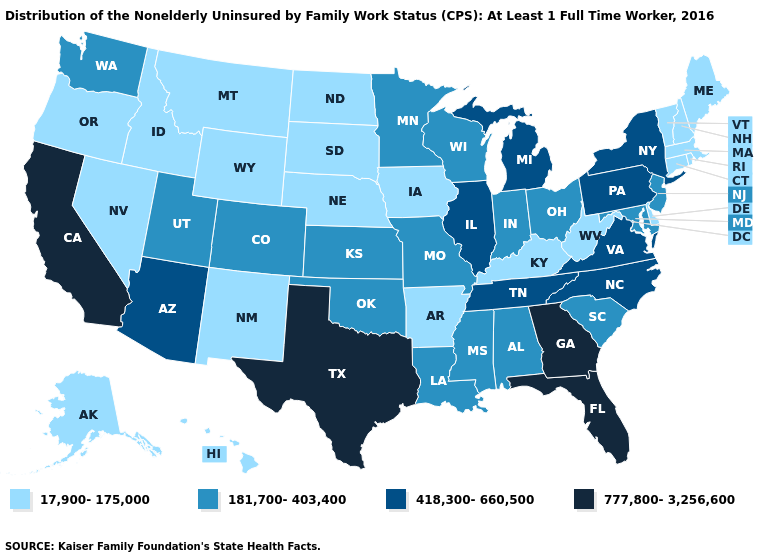Does Maryland have the highest value in the South?
Quick response, please. No. Which states have the lowest value in the West?
Give a very brief answer. Alaska, Hawaii, Idaho, Montana, Nevada, New Mexico, Oregon, Wyoming. Does Iowa have a lower value than Kentucky?
Give a very brief answer. No. What is the value of Rhode Island?
Give a very brief answer. 17,900-175,000. What is the value of Montana?
Keep it brief. 17,900-175,000. Name the states that have a value in the range 418,300-660,500?
Short answer required. Arizona, Illinois, Michigan, New York, North Carolina, Pennsylvania, Tennessee, Virginia. Among the states that border Vermont , which have the highest value?
Keep it brief. New York. Name the states that have a value in the range 777,800-3,256,600?
Short answer required. California, Florida, Georgia, Texas. Name the states that have a value in the range 418,300-660,500?
Give a very brief answer. Arizona, Illinois, Michigan, New York, North Carolina, Pennsylvania, Tennessee, Virginia. Which states have the lowest value in the South?
Keep it brief. Arkansas, Delaware, Kentucky, West Virginia. What is the value of Minnesota?
Be succinct. 181,700-403,400. What is the highest value in the West ?
Quick response, please. 777,800-3,256,600. Does the first symbol in the legend represent the smallest category?
Keep it brief. Yes. What is the highest value in states that border Minnesota?
Concise answer only. 181,700-403,400. Name the states that have a value in the range 17,900-175,000?
Short answer required. Alaska, Arkansas, Connecticut, Delaware, Hawaii, Idaho, Iowa, Kentucky, Maine, Massachusetts, Montana, Nebraska, Nevada, New Hampshire, New Mexico, North Dakota, Oregon, Rhode Island, South Dakota, Vermont, West Virginia, Wyoming. 